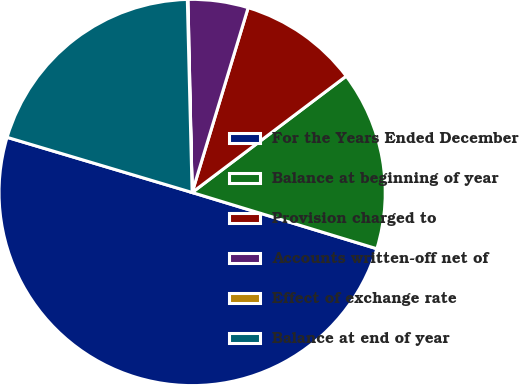Convert chart. <chart><loc_0><loc_0><loc_500><loc_500><pie_chart><fcel>For the Years Ended December<fcel>Balance at beginning of year<fcel>Provision charged to<fcel>Accounts written-off net of<fcel>Effect of exchange rate<fcel>Balance at end of year<nl><fcel>49.9%<fcel>15.0%<fcel>10.02%<fcel>5.03%<fcel>0.05%<fcel>19.99%<nl></chart> 